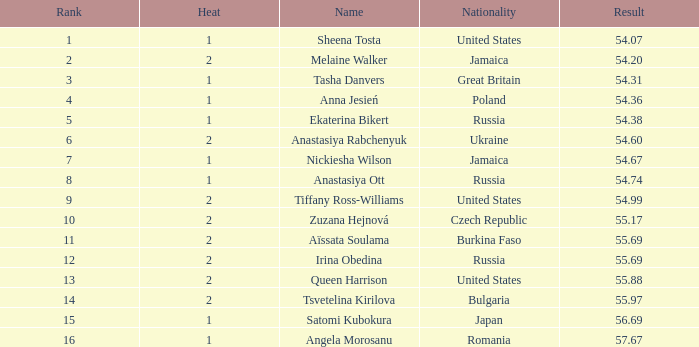Which Rank has a Name of tsvetelina kirilova, and a Result smaller than 55.97? None. 